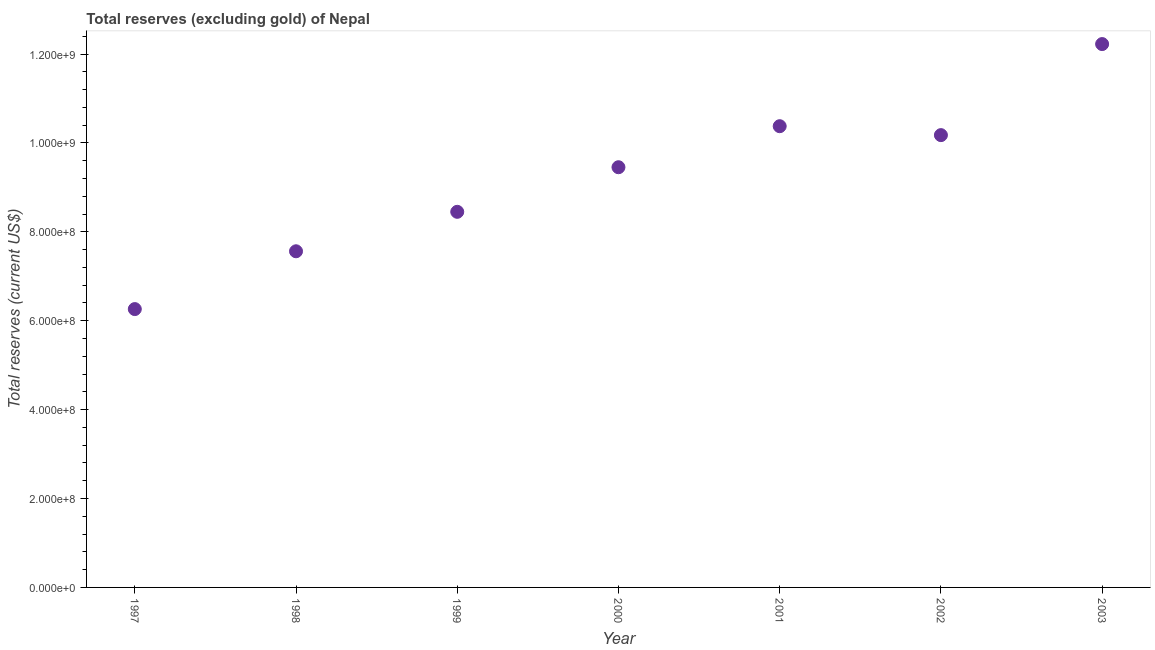What is the total reserves (excluding gold) in 1997?
Ensure brevity in your answer.  6.26e+08. Across all years, what is the maximum total reserves (excluding gold)?
Your response must be concise. 1.22e+09. Across all years, what is the minimum total reserves (excluding gold)?
Make the answer very short. 6.26e+08. In which year was the total reserves (excluding gold) minimum?
Provide a short and direct response. 1997. What is the sum of the total reserves (excluding gold)?
Make the answer very short. 6.45e+09. What is the difference between the total reserves (excluding gold) in 1999 and 2001?
Offer a terse response. -1.93e+08. What is the average total reserves (excluding gold) per year?
Keep it short and to the point. 9.22e+08. What is the median total reserves (excluding gold)?
Your response must be concise. 9.45e+08. In how many years, is the total reserves (excluding gold) greater than 160000000 US$?
Your answer should be very brief. 7. Do a majority of the years between 1998 and 1997 (inclusive) have total reserves (excluding gold) greater than 440000000 US$?
Keep it short and to the point. No. What is the ratio of the total reserves (excluding gold) in 2001 to that in 2002?
Offer a terse response. 1.02. Is the total reserves (excluding gold) in 2000 less than that in 2001?
Provide a succinct answer. Yes. What is the difference between the highest and the second highest total reserves (excluding gold)?
Offer a terse response. 1.85e+08. What is the difference between the highest and the lowest total reserves (excluding gold)?
Provide a succinct answer. 5.96e+08. In how many years, is the total reserves (excluding gold) greater than the average total reserves (excluding gold) taken over all years?
Your answer should be compact. 4. What is the difference between two consecutive major ticks on the Y-axis?
Your response must be concise. 2.00e+08. Does the graph contain grids?
Provide a short and direct response. No. What is the title of the graph?
Your answer should be compact. Total reserves (excluding gold) of Nepal. What is the label or title of the X-axis?
Your answer should be compact. Year. What is the label or title of the Y-axis?
Your answer should be very brief. Total reserves (current US$). What is the Total reserves (current US$) in 1997?
Your answer should be very brief. 6.26e+08. What is the Total reserves (current US$) in 1998?
Offer a terse response. 7.56e+08. What is the Total reserves (current US$) in 1999?
Your answer should be compact. 8.45e+08. What is the Total reserves (current US$) in 2000?
Your response must be concise. 9.45e+08. What is the Total reserves (current US$) in 2001?
Ensure brevity in your answer.  1.04e+09. What is the Total reserves (current US$) in 2002?
Your response must be concise. 1.02e+09. What is the Total reserves (current US$) in 2003?
Give a very brief answer. 1.22e+09. What is the difference between the Total reserves (current US$) in 1997 and 1998?
Your answer should be very brief. -1.30e+08. What is the difference between the Total reserves (current US$) in 1997 and 1999?
Make the answer very short. -2.19e+08. What is the difference between the Total reserves (current US$) in 1997 and 2000?
Keep it short and to the point. -3.19e+08. What is the difference between the Total reserves (current US$) in 1997 and 2001?
Offer a very short reply. -4.11e+08. What is the difference between the Total reserves (current US$) in 1997 and 2002?
Ensure brevity in your answer.  -3.91e+08. What is the difference between the Total reserves (current US$) in 1997 and 2003?
Provide a succinct answer. -5.96e+08. What is the difference between the Total reserves (current US$) in 1998 and 1999?
Your answer should be very brief. -8.88e+07. What is the difference between the Total reserves (current US$) in 1998 and 2000?
Ensure brevity in your answer.  -1.89e+08. What is the difference between the Total reserves (current US$) in 1998 and 2001?
Offer a very short reply. -2.81e+08. What is the difference between the Total reserves (current US$) in 1998 and 2002?
Make the answer very short. -2.61e+08. What is the difference between the Total reserves (current US$) in 1998 and 2003?
Offer a very short reply. -4.66e+08. What is the difference between the Total reserves (current US$) in 1999 and 2000?
Offer a very short reply. -1.00e+08. What is the difference between the Total reserves (current US$) in 1999 and 2001?
Provide a succinct answer. -1.93e+08. What is the difference between the Total reserves (current US$) in 1999 and 2002?
Provide a succinct answer. -1.73e+08. What is the difference between the Total reserves (current US$) in 1999 and 2003?
Offer a very short reply. -3.77e+08. What is the difference between the Total reserves (current US$) in 2000 and 2001?
Your answer should be very brief. -9.23e+07. What is the difference between the Total reserves (current US$) in 2000 and 2002?
Your response must be concise. -7.22e+07. What is the difference between the Total reserves (current US$) in 2000 and 2003?
Give a very brief answer. -2.77e+08. What is the difference between the Total reserves (current US$) in 2001 and 2002?
Keep it short and to the point. 2.01e+07. What is the difference between the Total reserves (current US$) in 2001 and 2003?
Ensure brevity in your answer.  -1.85e+08. What is the difference between the Total reserves (current US$) in 2002 and 2003?
Ensure brevity in your answer.  -2.05e+08. What is the ratio of the Total reserves (current US$) in 1997 to that in 1998?
Ensure brevity in your answer.  0.83. What is the ratio of the Total reserves (current US$) in 1997 to that in 1999?
Provide a short and direct response. 0.74. What is the ratio of the Total reserves (current US$) in 1997 to that in 2000?
Provide a short and direct response. 0.66. What is the ratio of the Total reserves (current US$) in 1997 to that in 2001?
Provide a short and direct response. 0.6. What is the ratio of the Total reserves (current US$) in 1997 to that in 2002?
Offer a terse response. 0.61. What is the ratio of the Total reserves (current US$) in 1997 to that in 2003?
Your response must be concise. 0.51. What is the ratio of the Total reserves (current US$) in 1998 to that in 1999?
Ensure brevity in your answer.  0.9. What is the ratio of the Total reserves (current US$) in 1998 to that in 2000?
Your response must be concise. 0.8. What is the ratio of the Total reserves (current US$) in 1998 to that in 2001?
Your answer should be very brief. 0.73. What is the ratio of the Total reserves (current US$) in 1998 to that in 2002?
Provide a short and direct response. 0.74. What is the ratio of the Total reserves (current US$) in 1998 to that in 2003?
Provide a succinct answer. 0.62. What is the ratio of the Total reserves (current US$) in 1999 to that in 2000?
Ensure brevity in your answer.  0.89. What is the ratio of the Total reserves (current US$) in 1999 to that in 2001?
Give a very brief answer. 0.81. What is the ratio of the Total reserves (current US$) in 1999 to that in 2002?
Keep it short and to the point. 0.83. What is the ratio of the Total reserves (current US$) in 1999 to that in 2003?
Your answer should be very brief. 0.69. What is the ratio of the Total reserves (current US$) in 2000 to that in 2001?
Keep it short and to the point. 0.91. What is the ratio of the Total reserves (current US$) in 2000 to that in 2002?
Give a very brief answer. 0.93. What is the ratio of the Total reserves (current US$) in 2000 to that in 2003?
Make the answer very short. 0.77. What is the ratio of the Total reserves (current US$) in 2001 to that in 2002?
Your answer should be very brief. 1.02. What is the ratio of the Total reserves (current US$) in 2001 to that in 2003?
Offer a terse response. 0.85. What is the ratio of the Total reserves (current US$) in 2002 to that in 2003?
Give a very brief answer. 0.83. 